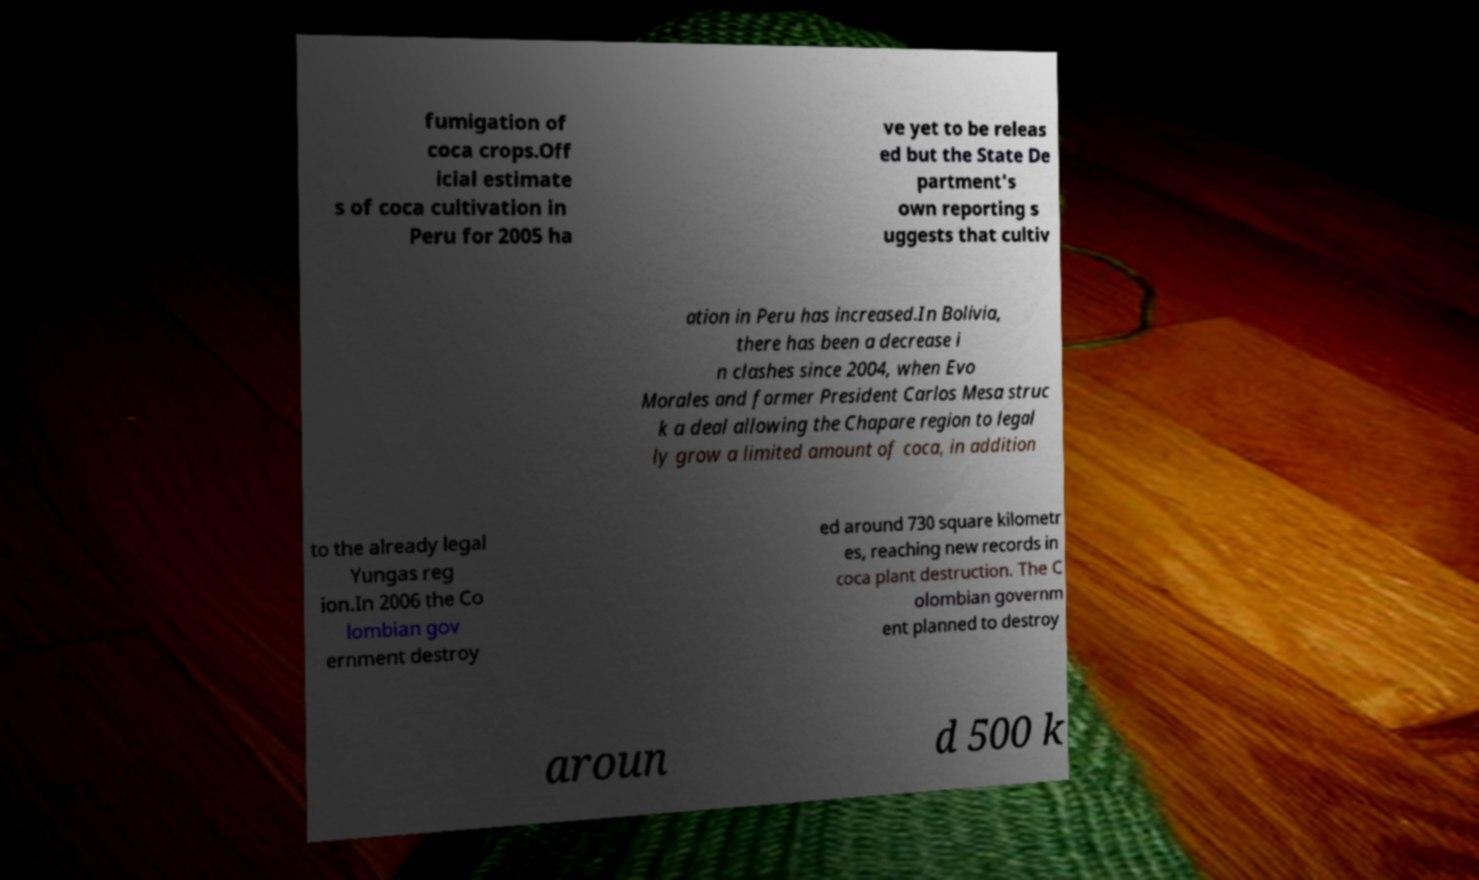What messages or text are displayed in this image? I need them in a readable, typed format. fumigation of coca crops.Off icial estimate s of coca cultivation in Peru for 2005 ha ve yet to be releas ed but the State De partment's own reporting s uggests that cultiv ation in Peru has increased.In Bolivia, there has been a decrease i n clashes since 2004, when Evo Morales and former President Carlos Mesa struc k a deal allowing the Chapare region to legal ly grow a limited amount of coca, in addition to the already legal Yungas reg ion.In 2006 the Co lombian gov ernment destroy ed around 730 square kilometr es, reaching new records in coca plant destruction. The C olombian governm ent planned to destroy aroun d 500 k 